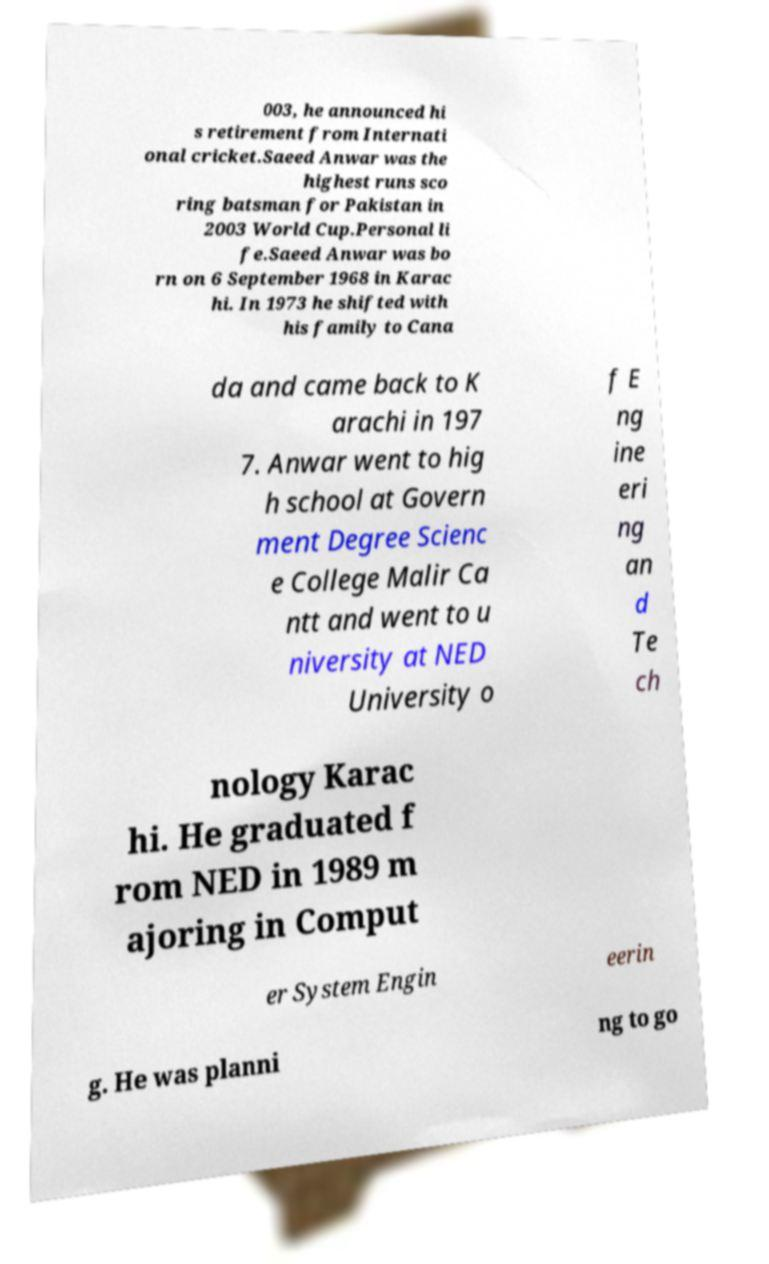What messages or text are displayed in this image? I need them in a readable, typed format. 003, he announced hi s retirement from Internati onal cricket.Saeed Anwar was the highest runs sco ring batsman for Pakistan in 2003 World Cup.Personal li fe.Saeed Anwar was bo rn on 6 September 1968 in Karac hi. In 1973 he shifted with his family to Cana da and came back to K arachi in 197 7. Anwar went to hig h school at Govern ment Degree Scienc e College Malir Ca ntt and went to u niversity at NED University o f E ng ine eri ng an d Te ch nology Karac hi. He graduated f rom NED in 1989 m ajoring in Comput er System Engin eerin g. He was planni ng to go 